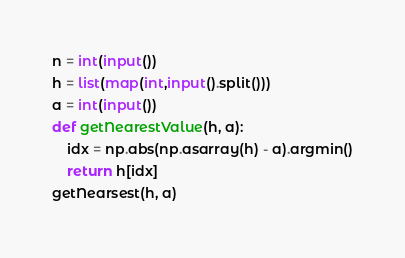<code> <loc_0><loc_0><loc_500><loc_500><_Python_>n = int(input())
h = list(map(int,input().split()))
a = int(input())
def getNearestValue(h, a):
	idx = np.abs(np.asarray(h) - a).argmin()
	return h[idx]
getNearsest(h, a)
</code> 